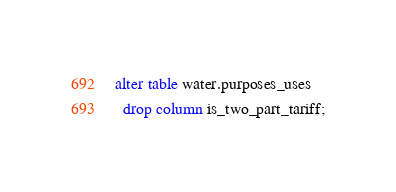Convert code to text. <code><loc_0><loc_0><loc_500><loc_500><_SQL_>alter table water.purposes_uses
  drop column is_two_part_tariff;
</code> 